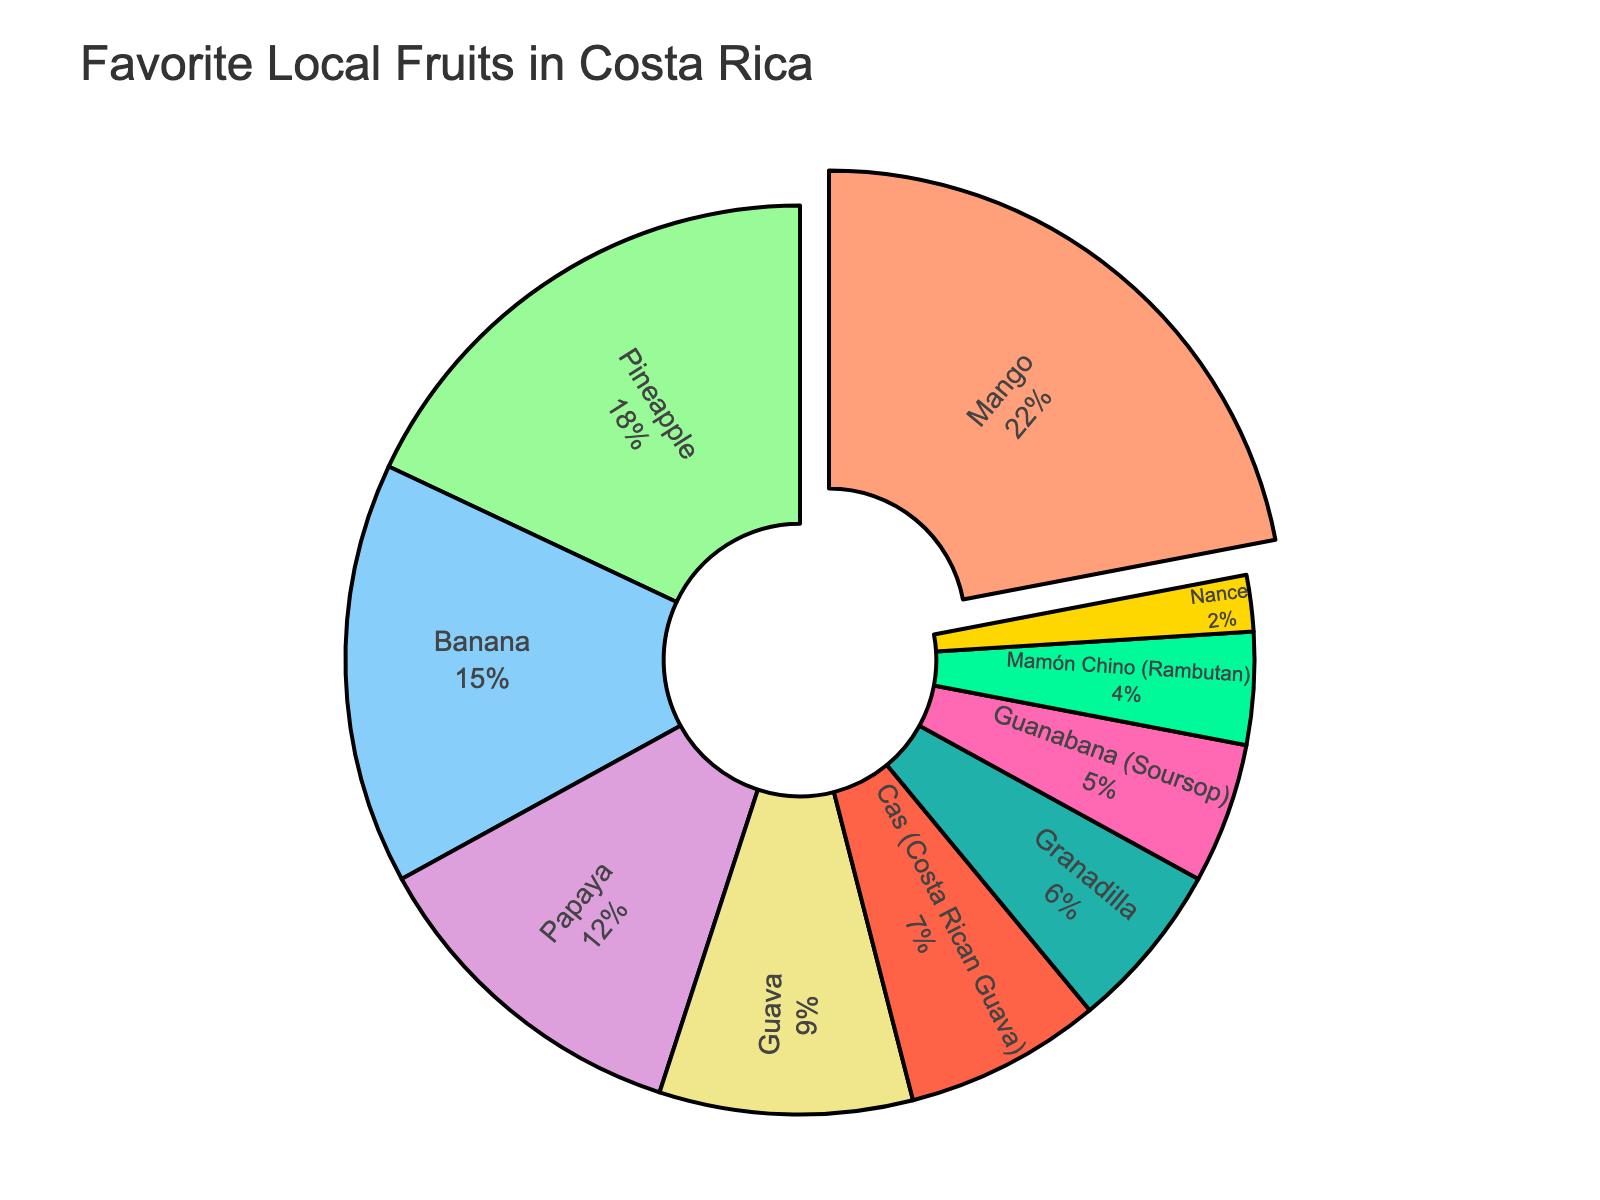what is the most favorite fruit in Costa Rica? The pie chart shows that mango has the largest slice, which indicates it is the most favorite fruit.
Answer: Mango what percentage of people prefer pineapple over banana? To find the percentage difference, subtract the percentage of banana (15%) from pineapple (18%): 18 - 15 = 3%.
Answer: 3% Among papaya, guava, and cas, which is preferred the least? The pie chart shows cas (Costa Rican guava) with 7%, papaya with 12%, and guava with 9%. Cas is the least preferred among the three.
Answer: Cas (Costa Rican guava) how much more popular is granadilla than nance? Granadilla has 6%, and nance has 2%. Subtract nance's percentage from granadilla's to find the difference: 6 - 2 = 4%.
Answer: 4% Which fruit has nearly double the preference of pineapple? Pineapple has 18%. Mango nearly has double, with 22%. Though it's slightly more than double, it fits the requirement best.
Answer: Mango what is the combined percentage of people who prefer guava and guanabana? The chart shows 9% for guava and 5% for guanabana. Add these percentages together: 9 + 5 = 14%.
Answer: 14% Is Mamón Chino or Nance preferred by a larger percentage of people? The pie chart shows 4% for Mamón Chino and 2% for Nance. Therefore, Mamón Chino is preferred by a larger percentage of people.
Answer: Mamón Chino which fruits make up more than 10% of the preferences? The pie chart shows mango (22%), pineapple (18%), banana (15%), and papaya (12%) as the fruits that make up more than 10%.
Answer: Mango, pineapple, banana, papaya What is the total percentage of the three least favored fruits? The chart lists the least favored as guanabana (5%), mamón chino (4%), and nance (2%). Add these percentages: 5 + 4 + 2 = 11%.
Answer: 11% compare the visual sizes of the pineapple and granadilla slices? The pineapple slice is visually much larger than the granadilla slice. Pineapple is 18%, while granadilla is only 6%, making pineapple's slice about three times larger.
Answer: Pineapple's slice is about three times larger than granadilla's 